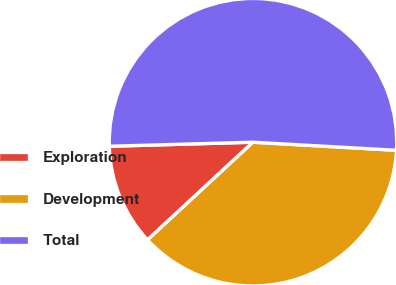<chart> <loc_0><loc_0><loc_500><loc_500><pie_chart><fcel>Exploration<fcel>Development<fcel>Total<nl><fcel>11.45%<fcel>37.21%<fcel>51.35%<nl></chart> 